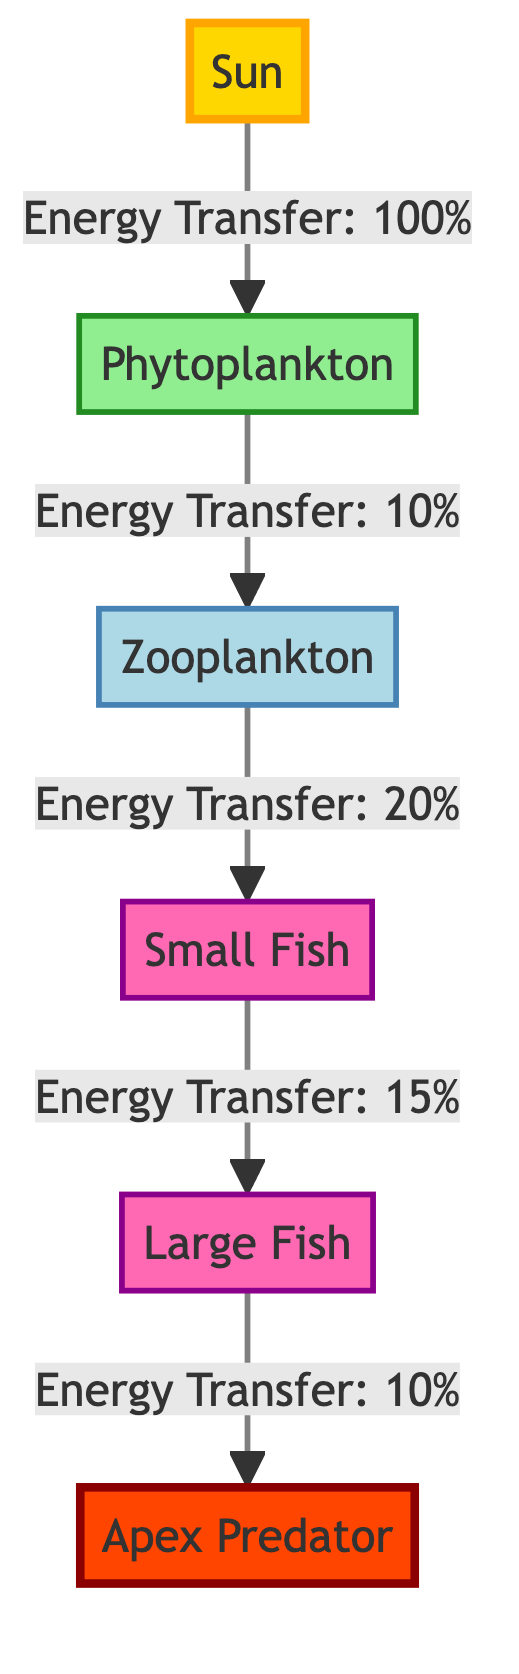What is the energy transfer efficiency from Sun to Phytoplankton? The diagram indicates that the energy transfer from the Sun to Phytoplankton is denoted as "Energy Transfer: 100%". This means that all available energy from the Sun is transferred to Phytoplankton.
Answer: 100% How many trophic levels are represented in this diagram? The diagram shows five nodes representing different organisms (Sun, Phytoplankton, Zooplankton, Small Fish, Large Fish, Apex Predator). These nodes include primary producers and apex predators, covering all levels from producers to apex consumers. Therefore, there are five trophic levels represented.
Answer: 5 What is the energy transfer efficiency from Zooplankton to Small Fish? According to the diagram, the energy transfer from Zooplankton to Small Fish is labeled as "Energy Transfer: 20%". This indicates that only 20% of energy from Zooplankton is passed on to Small Fish.
Answer: 20% Which organism has the lowest energy transfer efficiency in this diagram? The diagram shows the energy transfer rates for each organism, with the lowest being "Energy Transfer: 10%" from Large Fish to Apex Predator. This means the Apex Predator receives the least amount of energy compared to all energy transfers presented.
Answer: Apex Predator What percentage of energy does the Phytoplankton contribute to the Zooplankton? The diagram specifies the energy transfer from Phytoplankton to Zooplankton as "Energy Transfer: 10%". Thus, Phytoplankton contributes 10% of its energy to Zooplankton in the food chain.
Answer: 10% What is the direct relationship between Small Fish and Large Fish in terms of energy transfer? The diagram states that the energy transfer from Small Fish to Large Fish is given as "Energy Transfer: 15%". This indicates that Small Fish directly contributes 15% of their energy to Large Fish in the food chain.
Answer: 15% Which node acts as a primary producer in this flow chart? In the diagram, the only node identified as a primary producer is Phytoplankton, which utilizes sunlight to produce energy. Therefore, it represents the source of energy for the subsequent consumers in the food chain.
Answer: Phytoplankton What is the cumulative energy loss from Sun to Apex Predator? To find the cumulative energy loss, we start from the Sun (100%), then transfer to Phytoplankton (100%), Zooplankton (10%), Small Fish (15%), and finally to Large Fish (10%). This results in a final energy transfer of 0.1 * 0.1 * 0.2 * 0.15 = 0.003 or 3%. The cumulative energy loss from the initial 100% to 3% is 97%.
Answer: 97% 